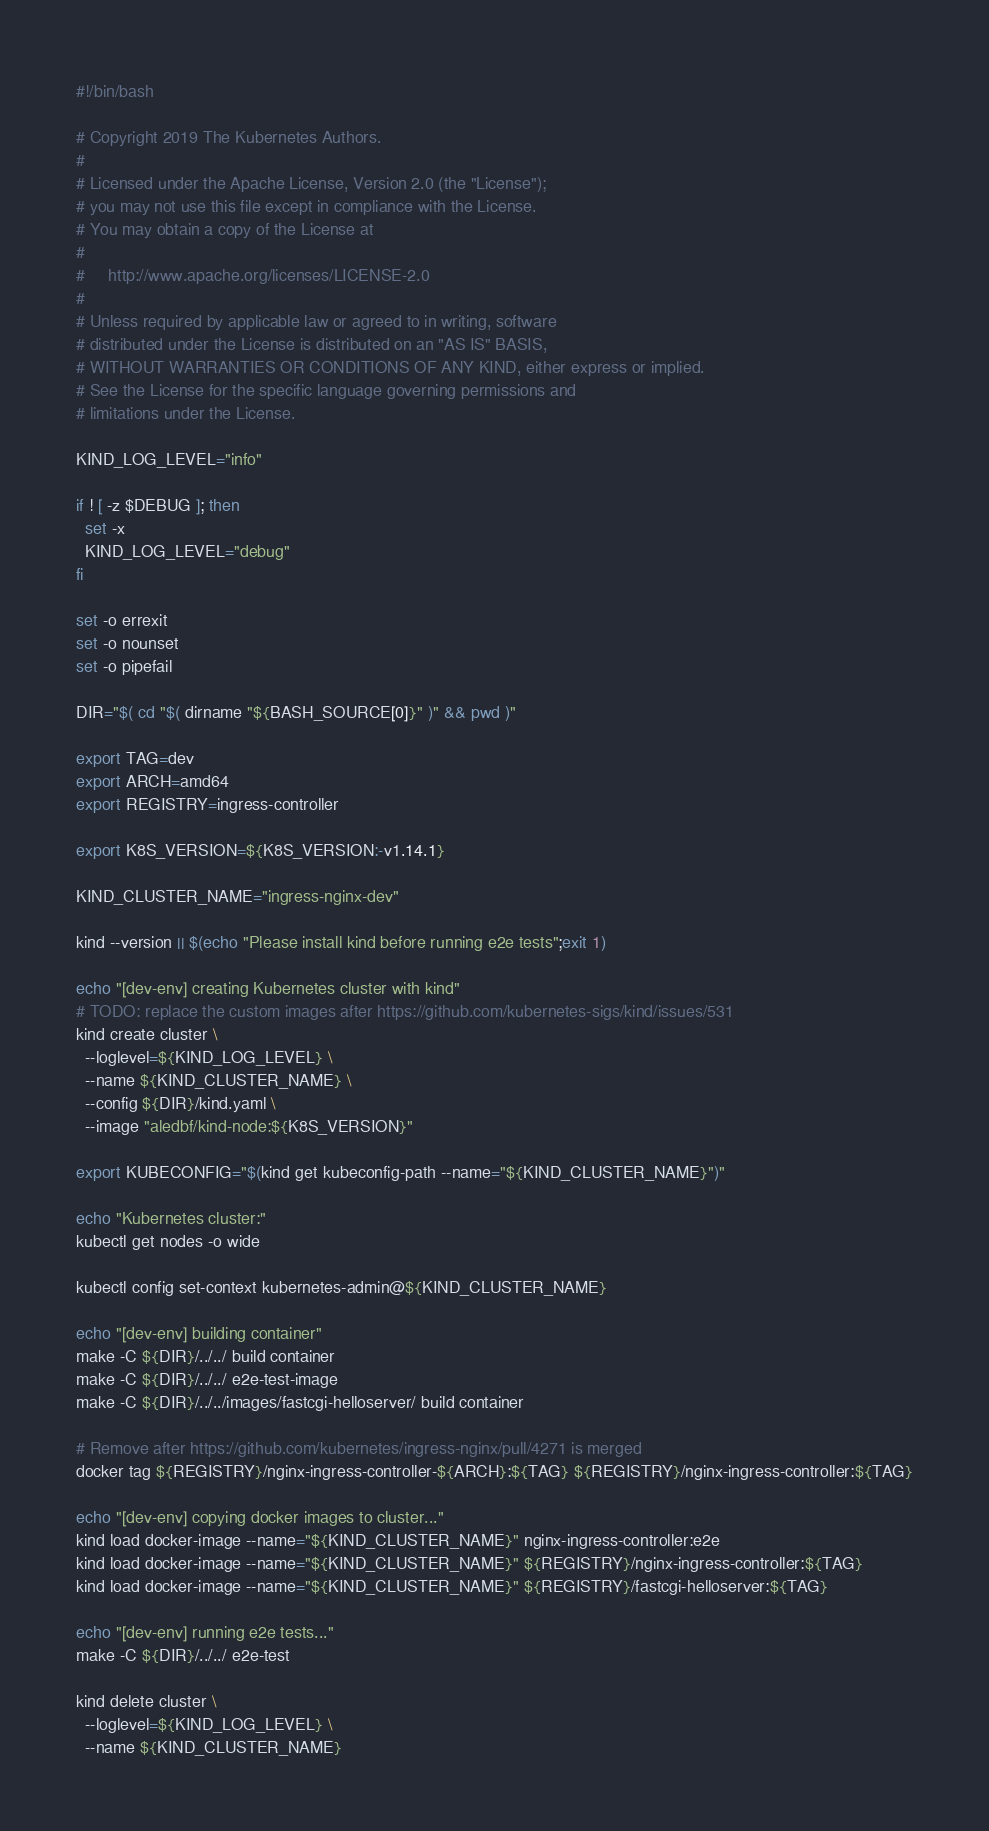Convert code to text. <code><loc_0><loc_0><loc_500><loc_500><_Bash_>#!/bin/bash

# Copyright 2019 The Kubernetes Authors.
#
# Licensed under the Apache License, Version 2.0 (the "License");
# you may not use this file except in compliance with the License.
# You may obtain a copy of the License at
#
#     http://www.apache.org/licenses/LICENSE-2.0
#
# Unless required by applicable law or agreed to in writing, software
# distributed under the License is distributed on an "AS IS" BASIS,
# WITHOUT WARRANTIES OR CONDITIONS OF ANY KIND, either express or implied.
# See the License for the specific language governing permissions and
# limitations under the License.

KIND_LOG_LEVEL="info"

if ! [ -z $DEBUG ]; then
  set -x
  KIND_LOG_LEVEL="debug"
fi

set -o errexit
set -o nounset
set -o pipefail

DIR="$( cd "$( dirname "${BASH_SOURCE[0]}" )" && pwd )"

export TAG=dev
export ARCH=amd64
export REGISTRY=ingress-controller

export K8S_VERSION=${K8S_VERSION:-v1.14.1}

KIND_CLUSTER_NAME="ingress-nginx-dev"

kind --version || $(echo "Please install kind before running e2e tests";exit 1)

echo "[dev-env] creating Kubernetes cluster with kind"
# TODO: replace the custom images after https://github.com/kubernetes-sigs/kind/issues/531
kind create cluster \
  --loglevel=${KIND_LOG_LEVEL} \
  --name ${KIND_CLUSTER_NAME} \
  --config ${DIR}/kind.yaml \
  --image "aledbf/kind-node:${K8S_VERSION}"

export KUBECONFIG="$(kind get kubeconfig-path --name="${KIND_CLUSTER_NAME}")"

echo "Kubernetes cluster:"
kubectl get nodes -o wide

kubectl config set-context kubernetes-admin@${KIND_CLUSTER_NAME}

echo "[dev-env] building container"
make -C ${DIR}/../../ build container
make -C ${DIR}/../../ e2e-test-image
make -C ${DIR}/../../images/fastcgi-helloserver/ build container

# Remove after https://github.com/kubernetes/ingress-nginx/pull/4271 is merged
docker tag ${REGISTRY}/nginx-ingress-controller-${ARCH}:${TAG} ${REGISTRY}/nginx-ingress-controller:${TAG}

echo "[dev-env] copying docker images to cluster..."
kind load docker-image --name="${KIND_CLUSTER_NAME}" nginx-ingress-controller:e2e
kind load docker-image --name="${KIND_CLUSTER_NAME}" ${REGISTRY}/nginx-ingress-controller:${TAG}
kind load docker-image --name="${KIND_CLUSTER_NAME}" ${REGISTRY}/fastcgi-helloserver:${TAG}

echo "[dev-env] running e2e tests..."
make -C ${DIR}/../../ e2e-test

kind delete cluster \
  --loglevel=${KIND_LOG_LEVEL} \
  --name ${KIND_CLUSTER_NAME}
</code> 